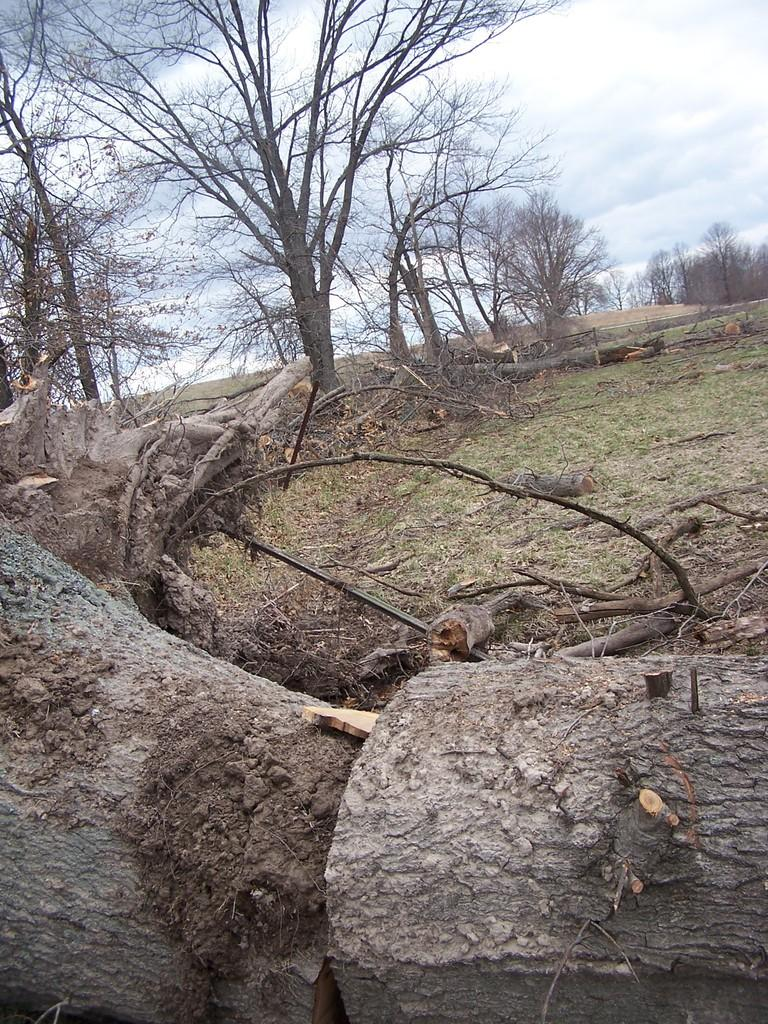What type of objects are made of wood in the image? There are wooden objects in the image. What type of natural environment is visible in the image? There is grass visible in the image. What can be seen in the background of the image? There are trees and the sky visible in the background of the image. What is the condition of the sky in the image? Clouds are present in the sky. Where is the faucet located in the image? There is no faucet present in the image. What type of spot can be seen on the wooden objects in the image? There are no spots visible on the wooden objects in the image. 